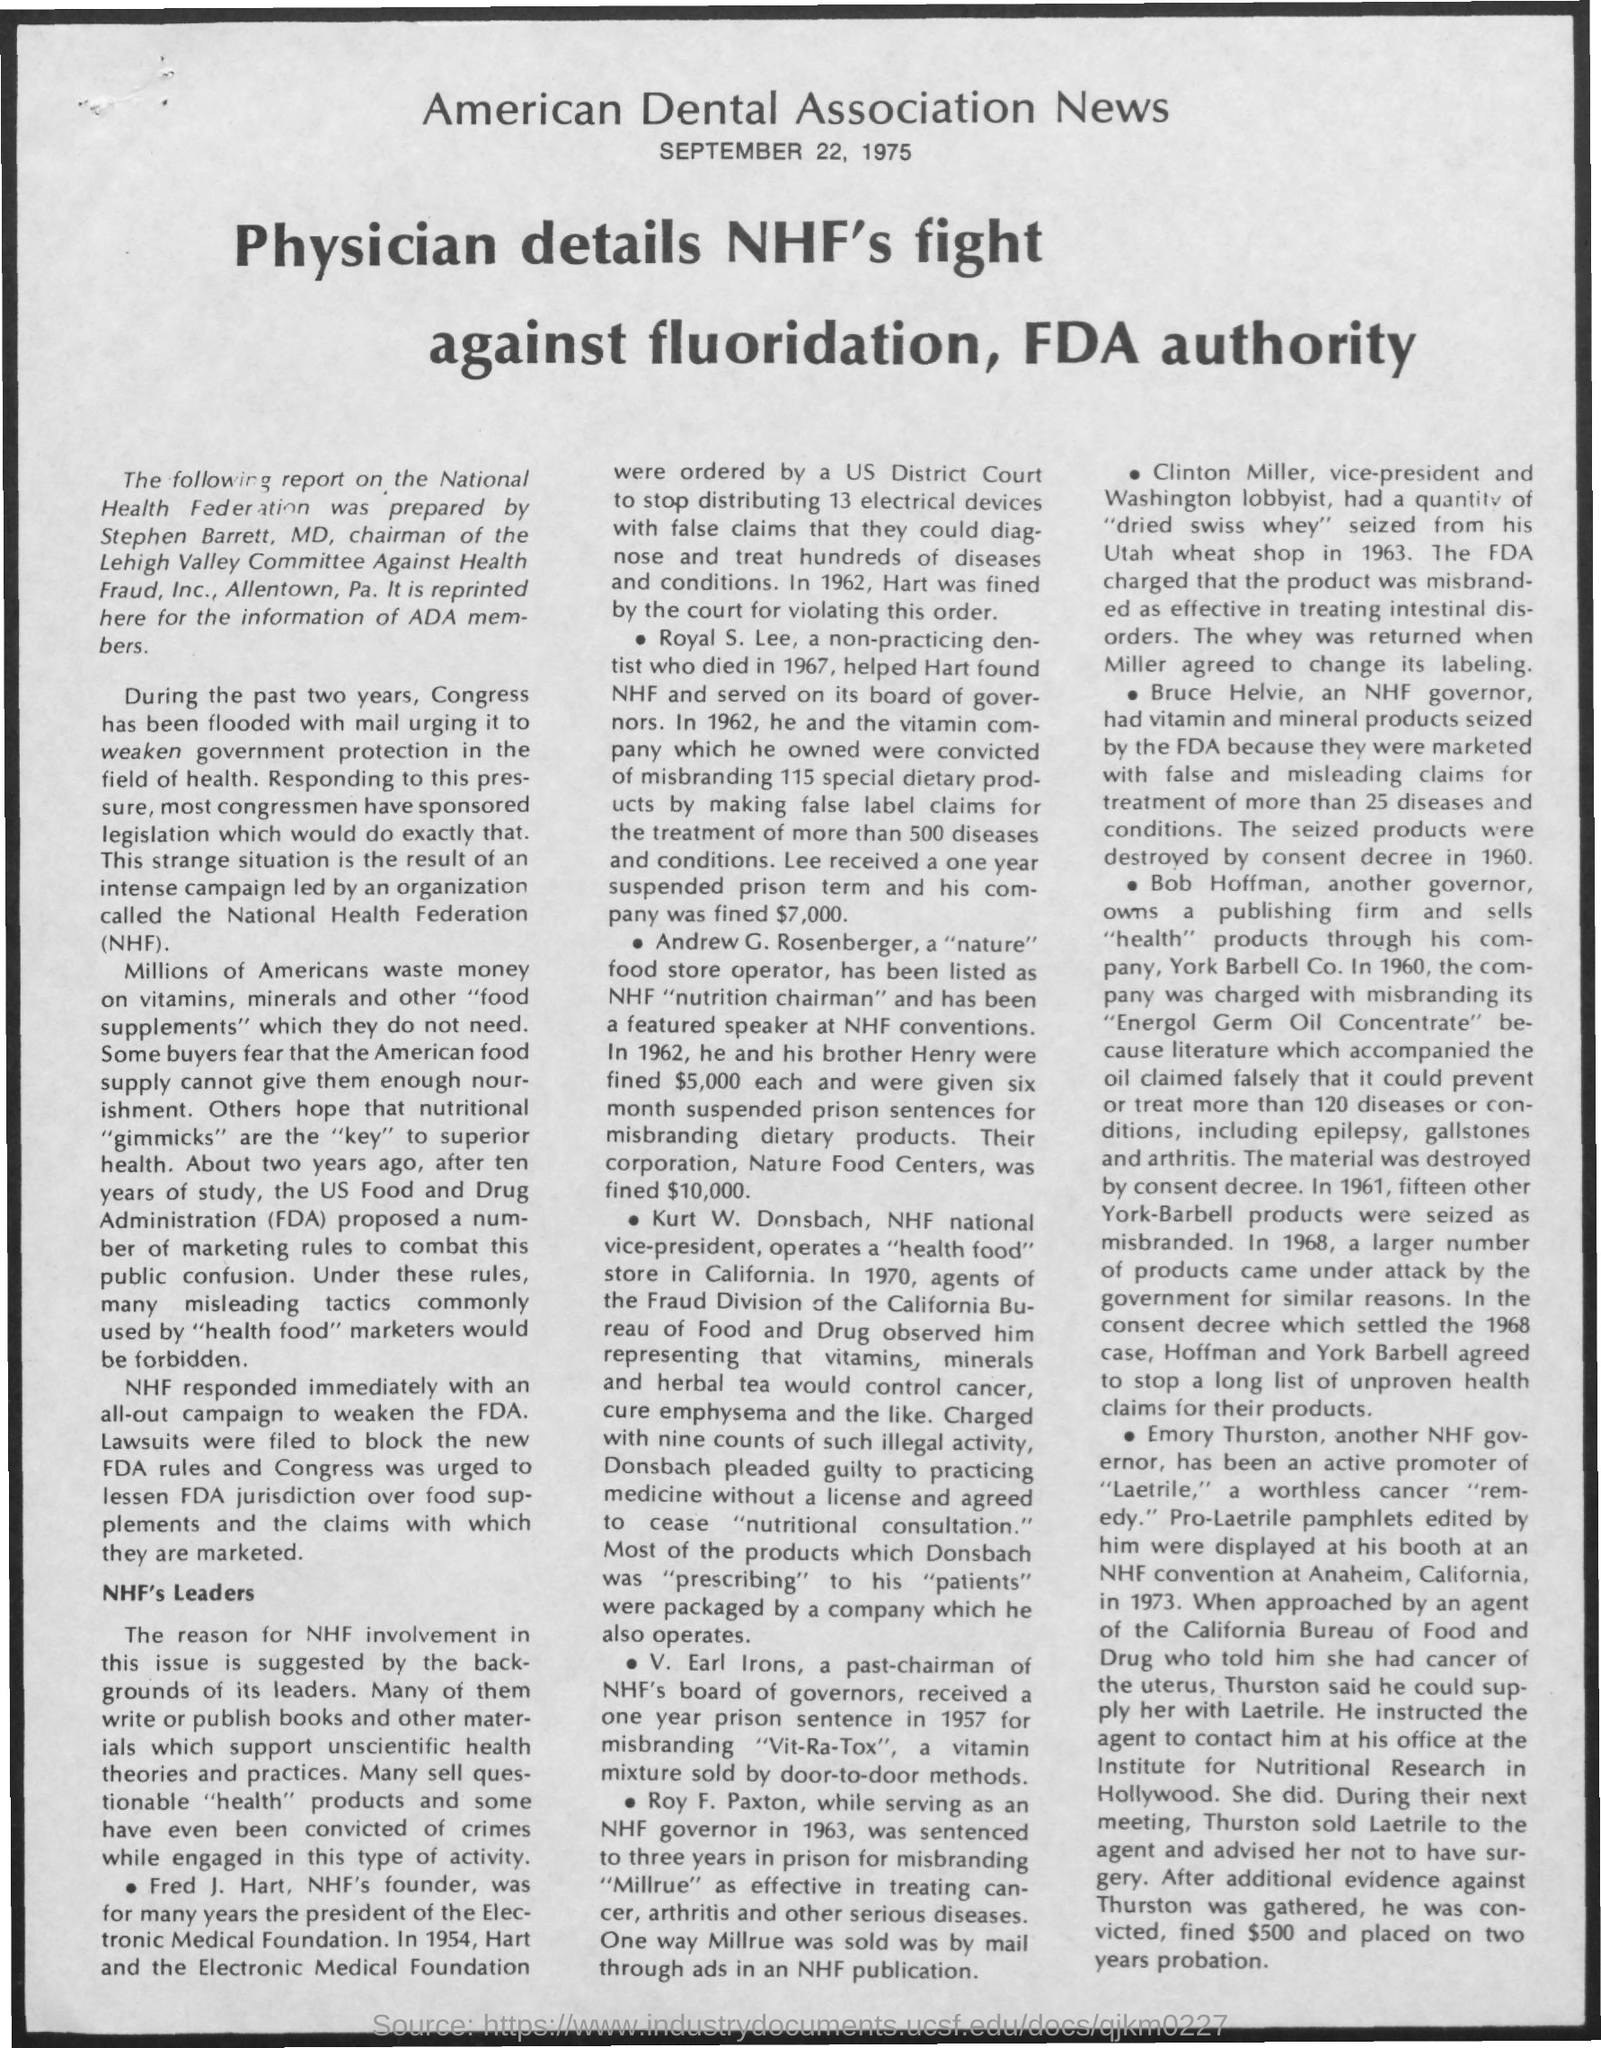From which newspaper is this taken from?
Ensure brevity in your answer.  American Dental Association News. When is the news article dated?
Offer a very short reply. SEPTEMBER 22, 1975. What is the full form of FDA?
Your response must be concise. Food and Drug Administration. Who is NHF's founder?
Your response must be concise. Fred J. Hart. 